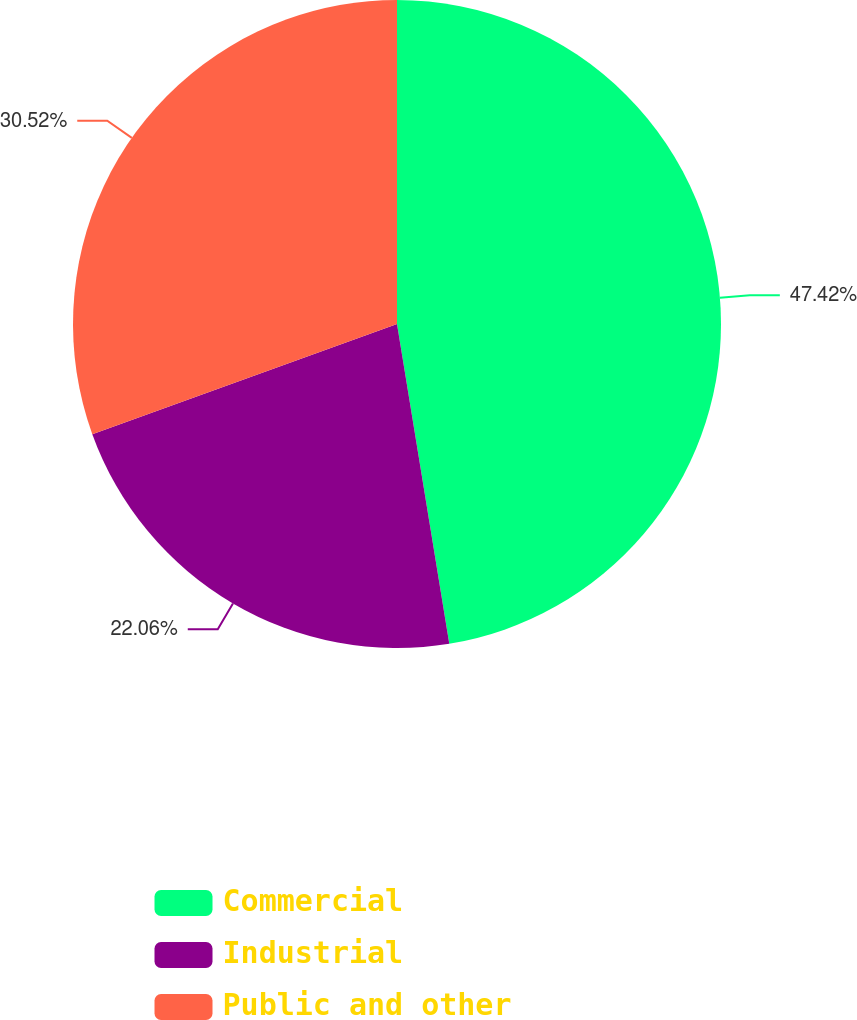Convert chart. <chart><loc_0><loc_0><loc_500><loc_500><pie_chart><fcel>Commercial<fcel>Industrial<fcel>Public and other<nl><fcel>47.42%<fcel>22.06%<fcel>30.52%<nl></chart> 